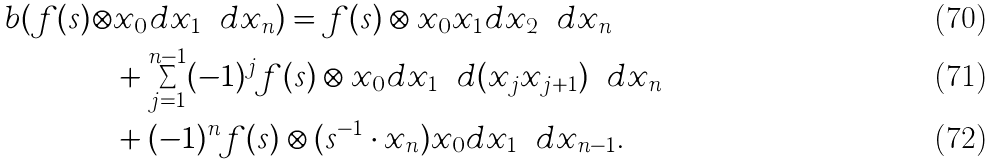<formula> <loc_0><loc_0><loc_500><loc_500>b ( f ( s ) \otimes & x _ { 0 } d x _ { 1 } \cdots d x _ { n } ) = f ( s ) \otimes x _ { 0 } x _ { 1 } d x _ { 2 } \cdots d x _ { n } \\ & + \sum _ { j = 1 } ^ { n - 1 } ( - 1 ) ^ { j } f ( s ) \otimes x _ { 0 } d x _ { 1 } \cdots d ( x _ { j } x _ { j + 1 } ) \cdots d x _ { n } \\ & + ( - 1 ) ^ { n } f ( s ) \otimes ( s ^ { - 1 } \cdot x _ { n } ) x _ { 0 } d x _ { 1 } \cdots d x _ { n - 1 } .</formula> 